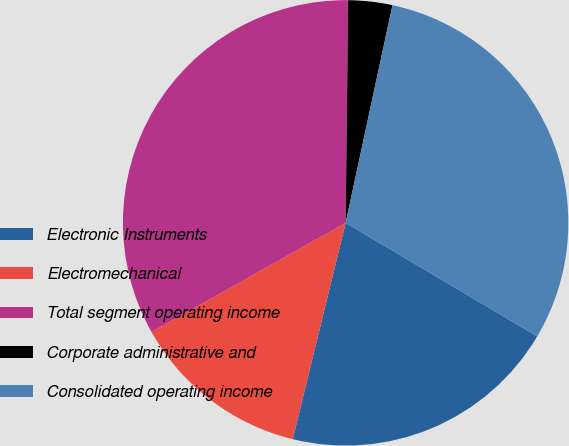Convert chart to OTSL. <chart><loc_0><loc_0><loc_500><loc_500><pie_chart><fcel>Electronic Instruments<fcel>Electromechanical<fcel>Total segment operating income<fcel>Corporate administrative and<fcel>Consolidated operating income<nl><fcel>20.3%<fcel>13.03%<fcel>33.33%<fcel>3.19%<fcel>30.14%<nl></chart> 